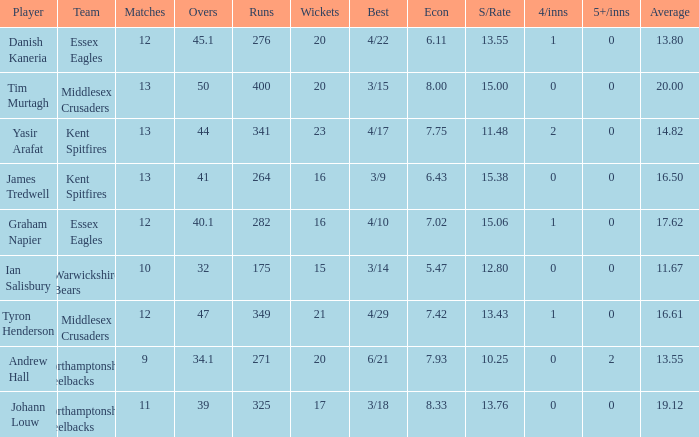Name the most 4/inns 2.0. 